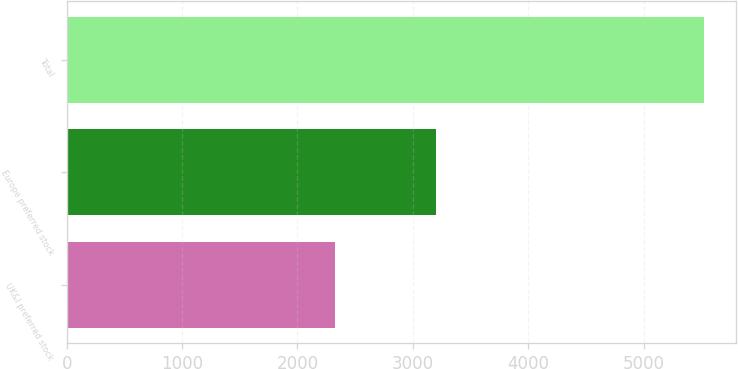Convert chart to OTSL. <chart><loc_0><loc_0><loc_500><loc_500><bar_chart><fcel>UK&I preferred stock<fcel>Europe preferred stock<fcel>Total<nl><fcel>2326<fcel>3200<fcel>5526<nl></chart> 